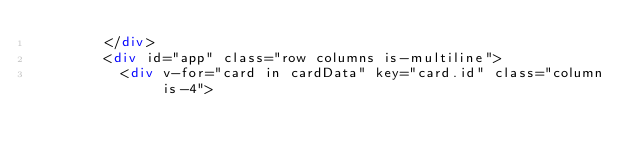<code> <loc_0><loc_0><loc_500><loc_500><_HTML_>        </div>
        <div id="app" class="row columns is-multiline">
          <div v-for="card in cardData" key="card.id" class="column is-4"></code> 